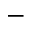<formula> <loc_0><loc_0><loc_500><loc_500>-</formula> 